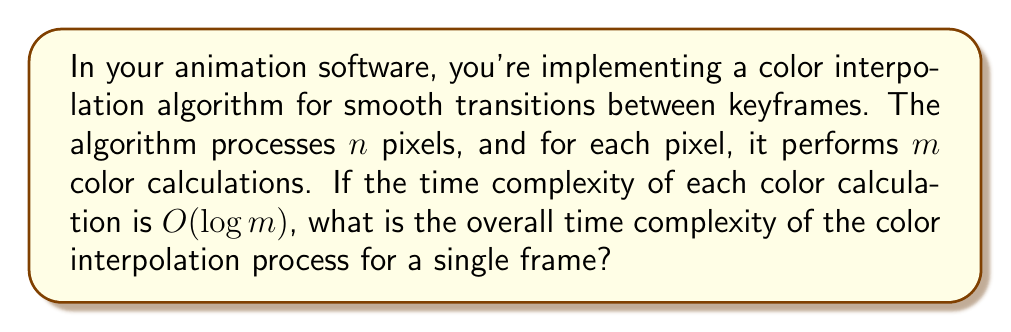Solve this math problem. Let's break this down step-by-step:

1. We have $n$ pixels to process.
2. For each pixel, we perform $m$ color calculations.
3. Each color calculation has a time complexity of $O(\log m)$.

To find the overall time complexity:

1. For a single pixel:
   - We perform $m$ calculations, each taking $O(\log m)$ time.
   - The time for one pixel is thus: $m \cdot O(\log m) = O(m \log m)$

2. For all $n$ pixels:
   - We repeat the $O(m \log m)$ process $n$ times.
   - The total time is therefore: $n \cdot O(m \log m) = O(nm \log m)$

Therefore, the overall time complexity for processing a single frame with this color interpolation algorithm is $O(nm \log m)$.

This complexity suggests that the algorithm's performance is influenced more by the number of color calculations per pixel $(m)$ than by the total number of pixels $(n)$, due to the logarithmic factor. As an animator, you might consider this when deciding on the precision of your color transitions or when optimizing for render time.
Answer: $O(nm \log m)$ 